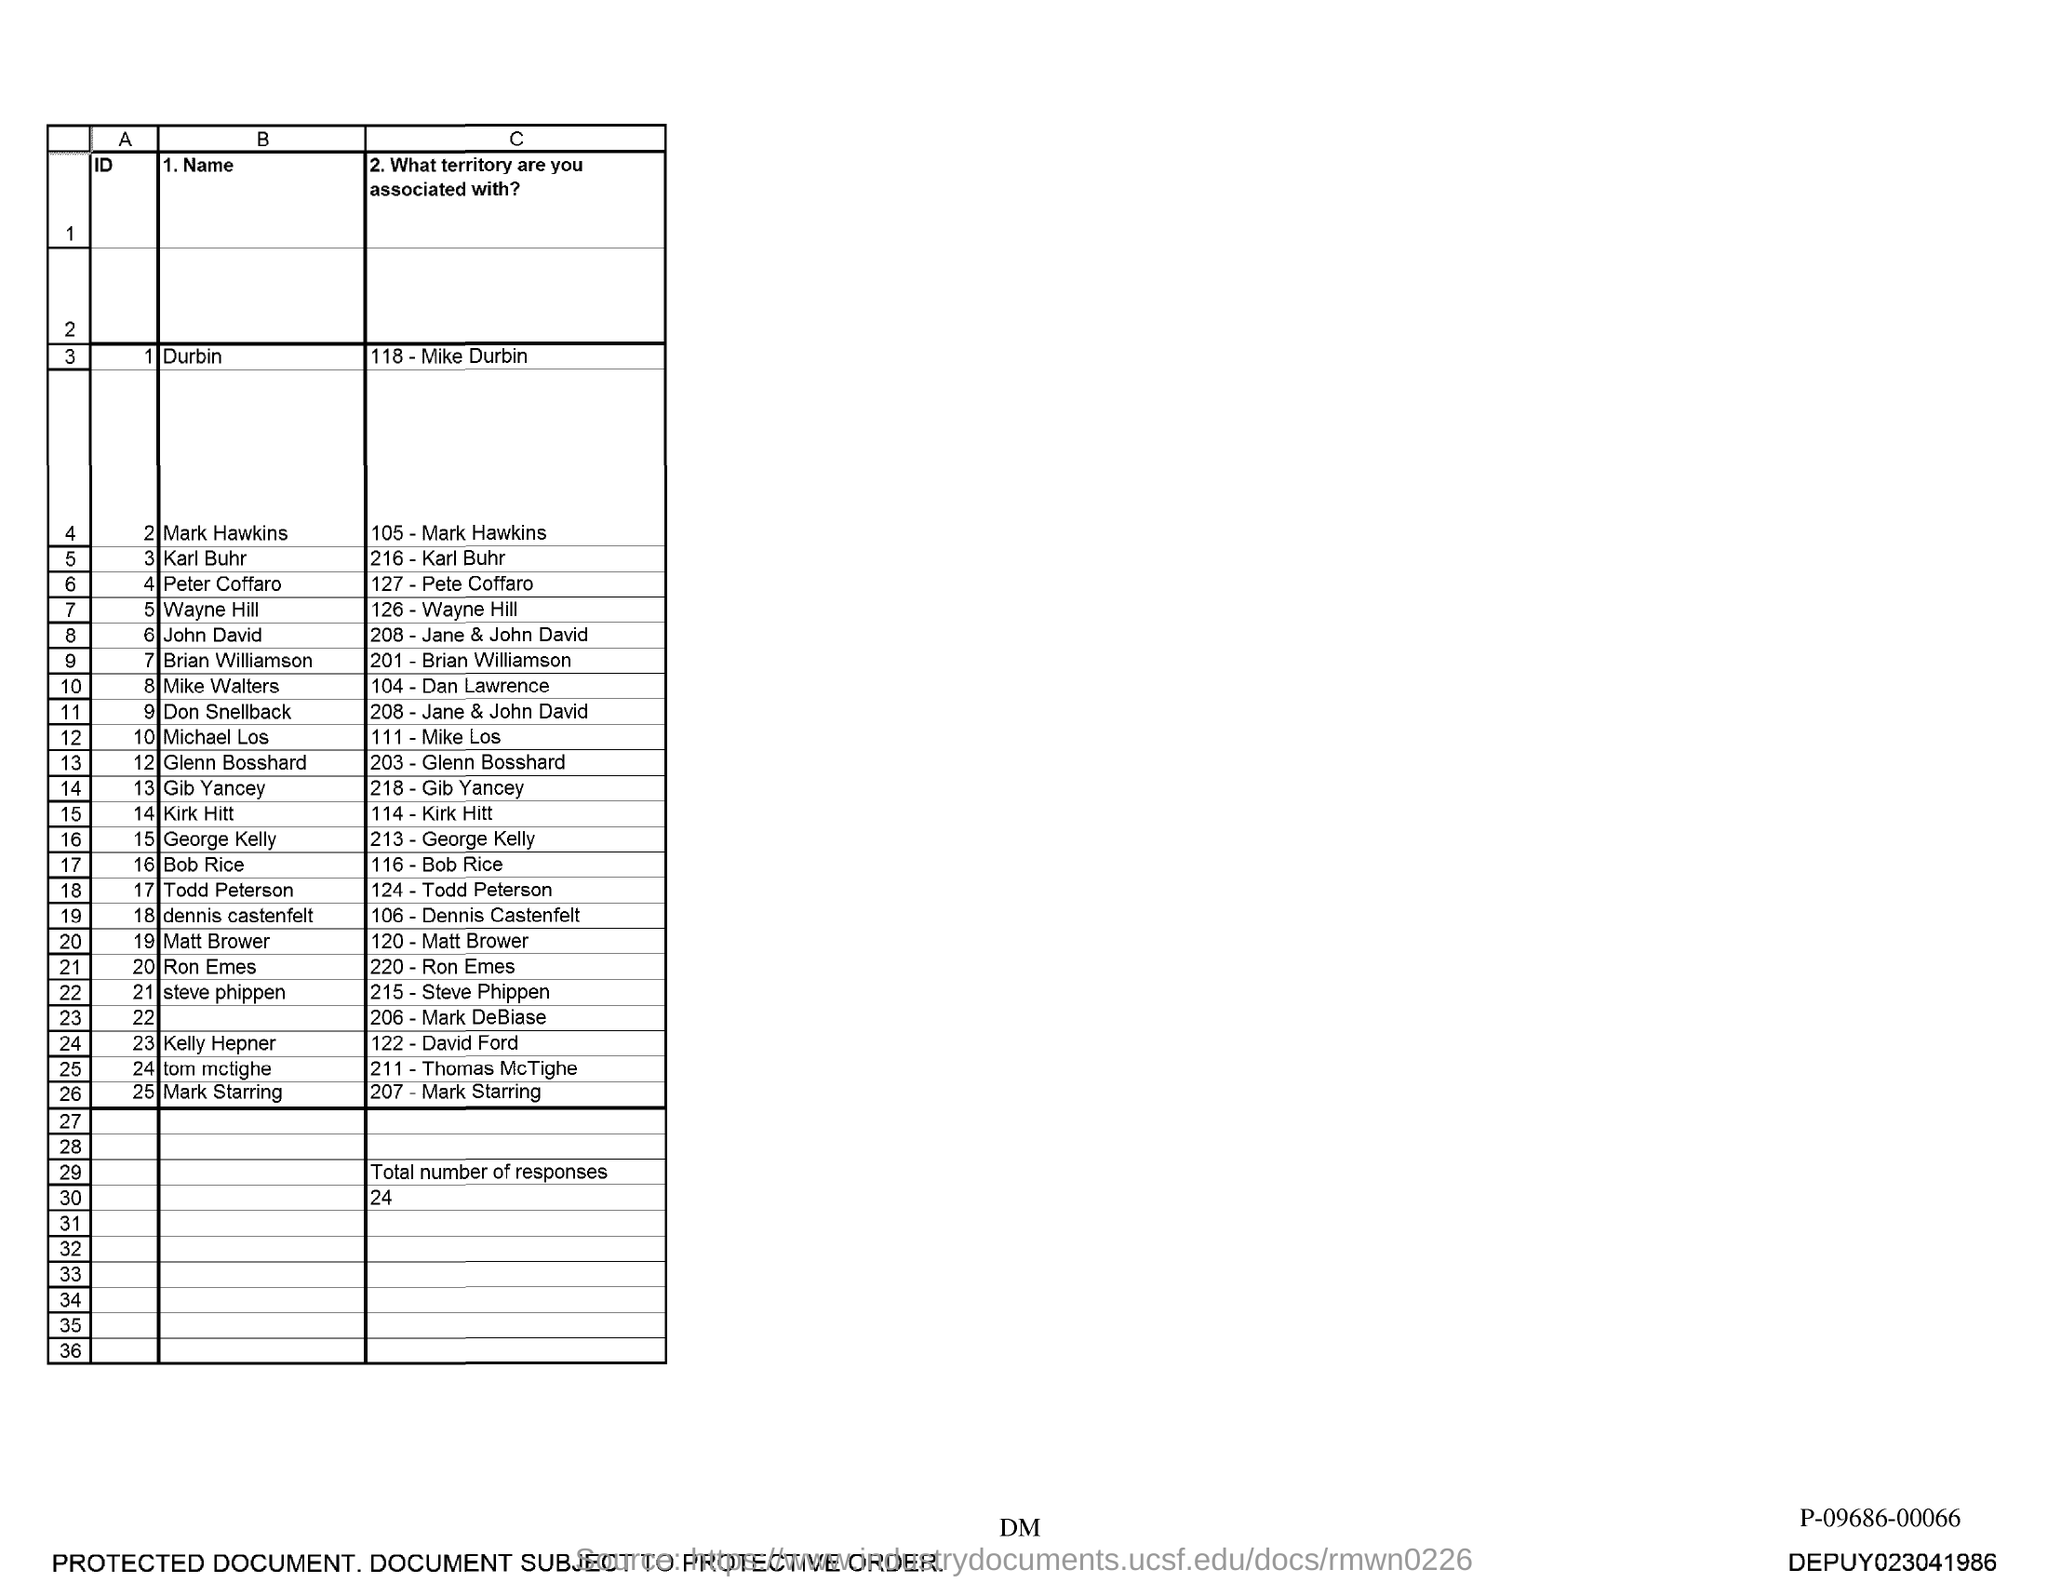What is the total number of responses?
Your response must be concise. 24. 